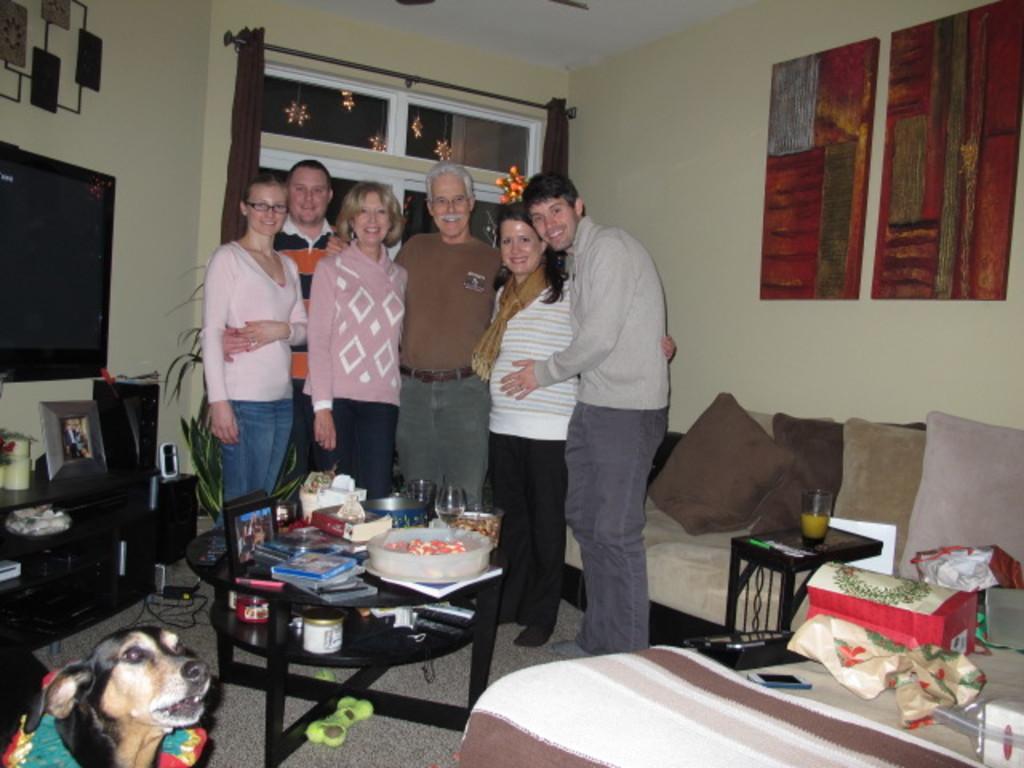Can you describe this image briefly? In this picture we can see a dog and group of people they are all standing, in front of them we can see photo frame, glasses, books and some other objects on the table and also we can find television, wall paintings, sofa, baggage and mobile. 